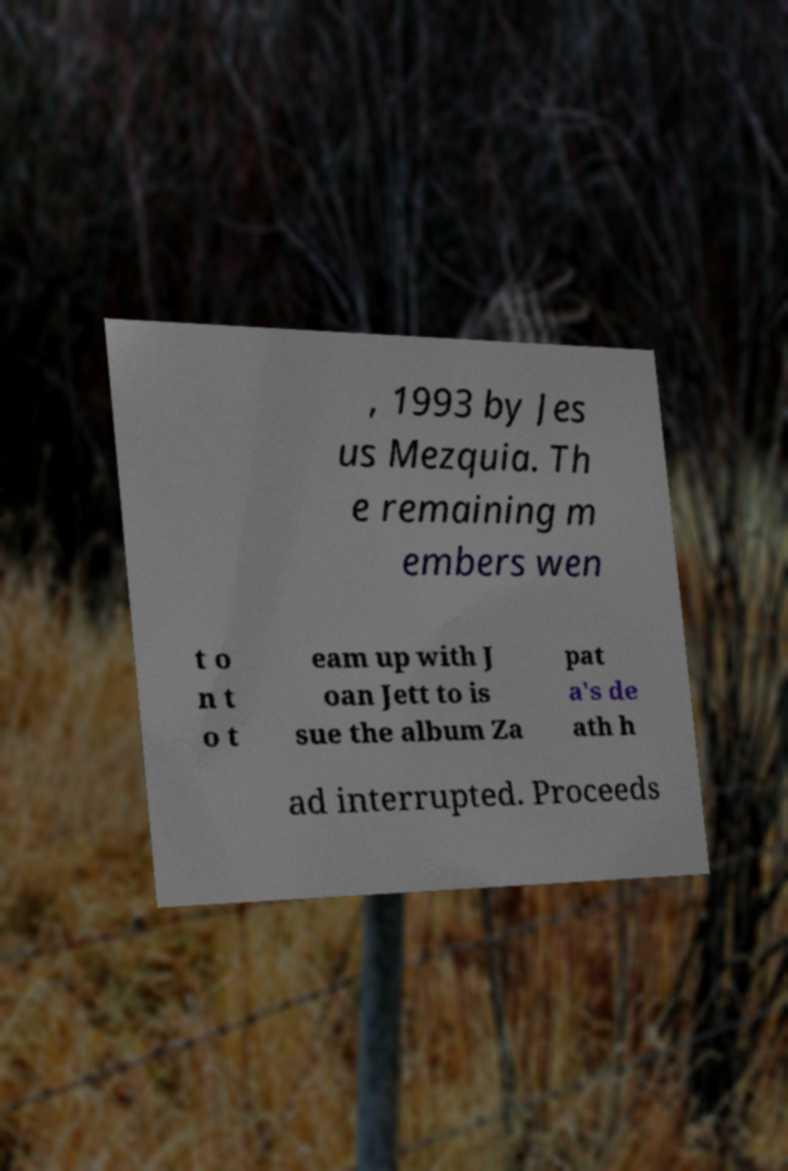Could you extract and type out the text from this image? , 1993 by Jes us Mezquia. Th e remaining m embers wen t o n t o t eam up with J oan Jett to is sue the album Za pat a's de ath h ad interrupted. Proceeds 